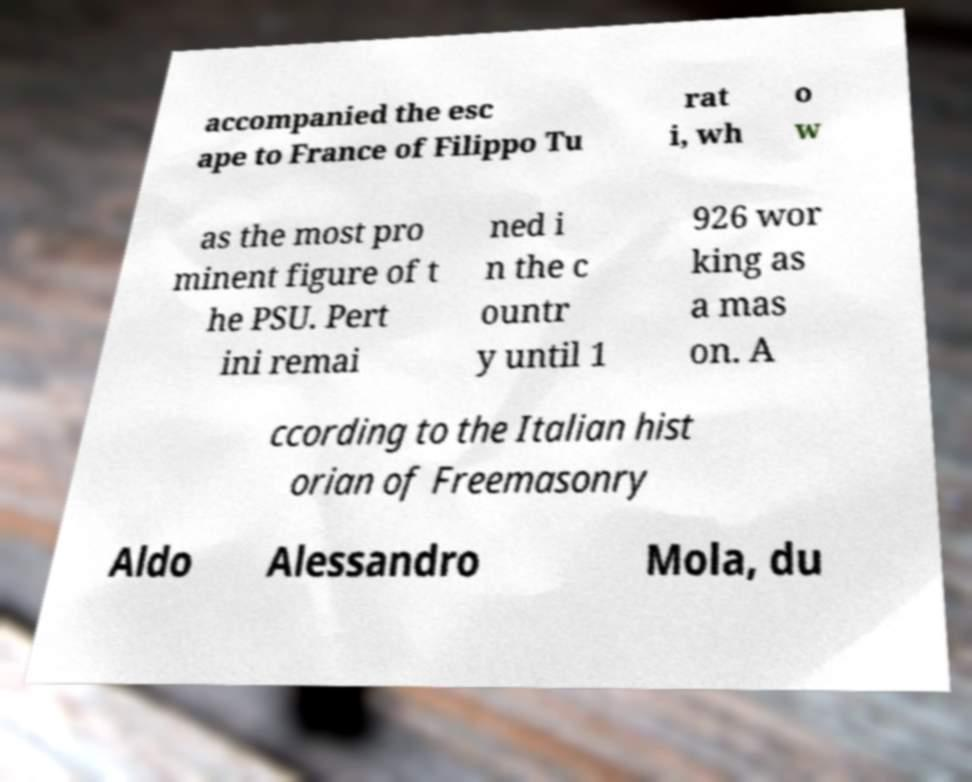For documentation purposes, I need the text within this image transcribed. Could you provide that? accompanied the esc ape to France of Filippo Tu rat i, wh o w as the most pro minent figure of t he PSU. Pert ini remai ned i n the c ountr y until 1 926 wor king as a mas on. A ccording to the Italian hist orian of Freemasonry Aldo Alessandro Mola, du 